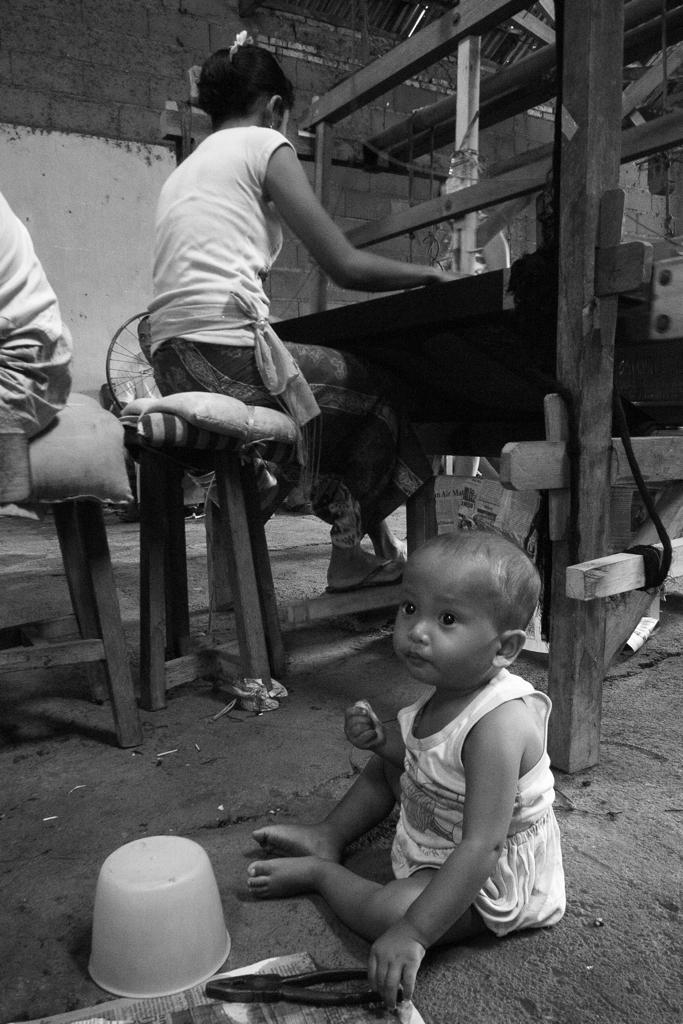How many people are present in the image? There are three people in the image. What is one of the people doing in the image? One of the people is working on a cloth weaving machine. What tool can be seen in the image? There is a cutting plier in the image. What is on the floor in the image? There is a box on the floor in the image. What is a feature of the background in the image? There is a wall in the image. What type of cart is being used to transport the nation in the image? There is no cart or nation present in the image. How is the payment being processed for the services provided in the image? There is no indication of payment or services being provided in the image. 